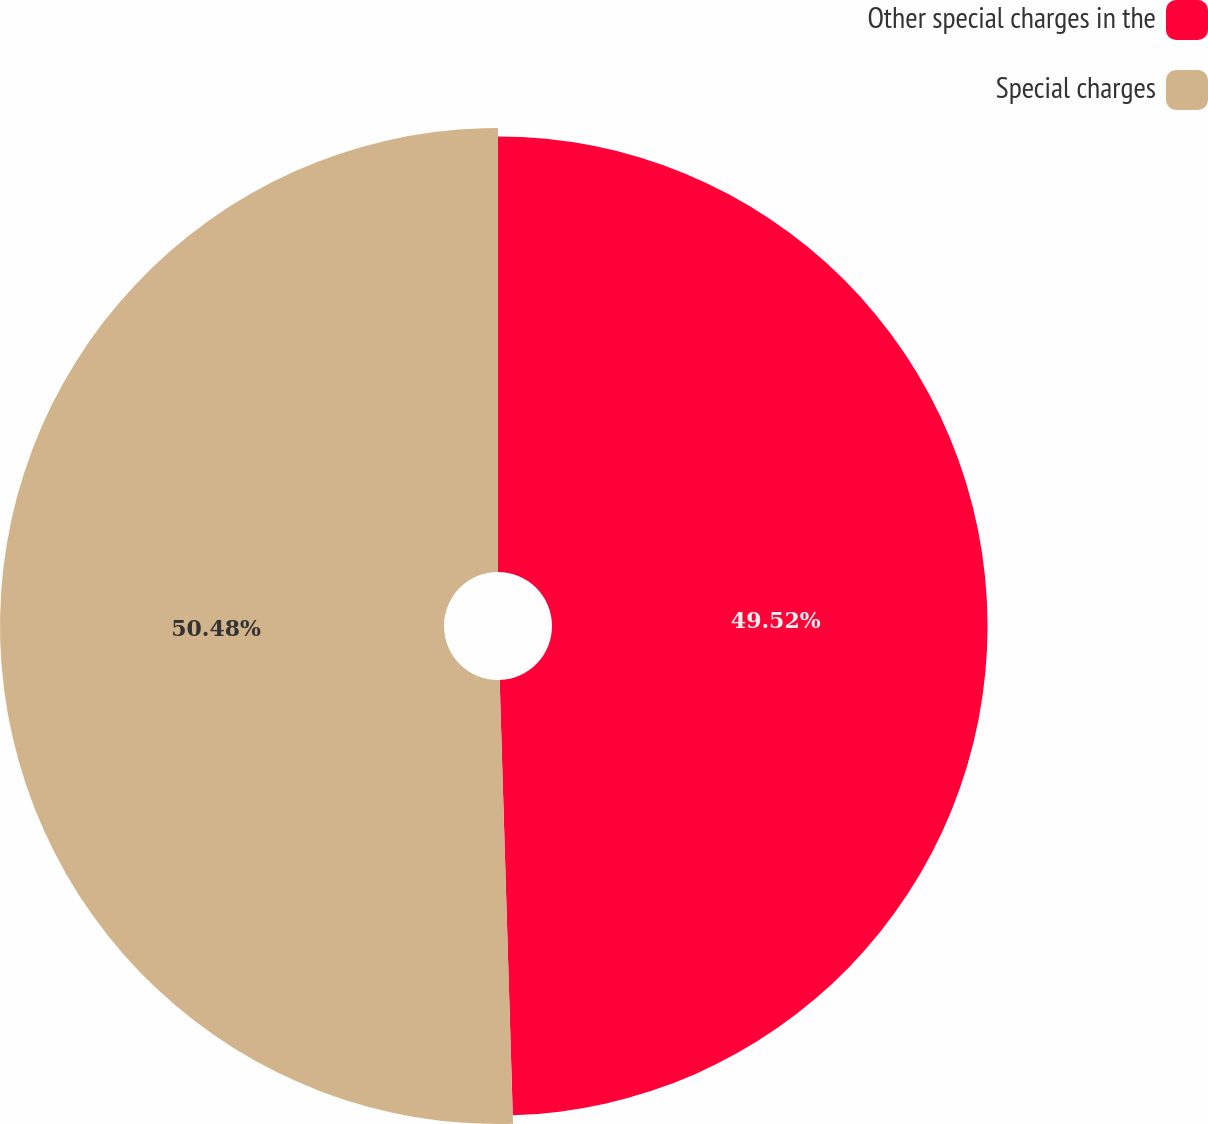<chart> <loc_0><loc_0><loc_500><loc_500><pie_chart><fcel>Other special charges in the<fcel>Special charges<nl><fcel>49.52%<fcel>50.48%<nl></chart> 